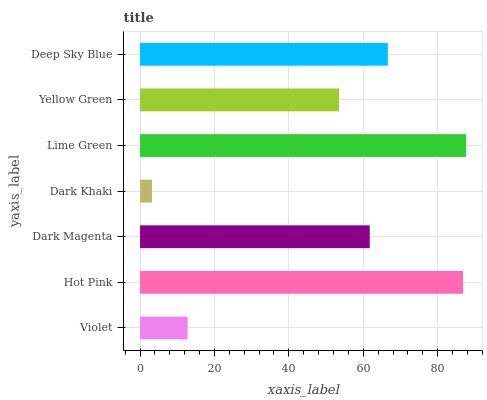Is Dark Khaki the minimum?
Answer yes or no. Yes. Is Lime Green the maximum?
Answer yes or no. Yes. Is Hot Pink the minimum?
Answer yes or no. No. Is Hot Pink the maximum?
Answer yes or no. No. Is Hot Pink greater than Violet?
Answer yes or no. Yes. Is Violet less than Hot Pink?
Answer yes or no. Yes. Is Violet greater than Hot Pink?
Answer yes or no. No. Is Hot Pink less than Violet?
Answer yes or no. No. Is Dark Magenta the high median?
Answer yes or no. Yes. Is Dark Magenta the low median?
Answer yes or no. Yes. Is Dark Khaki the high median?
Answer yes or no. No. Is Yellow Green the low median?
Answer yes or no. No. 